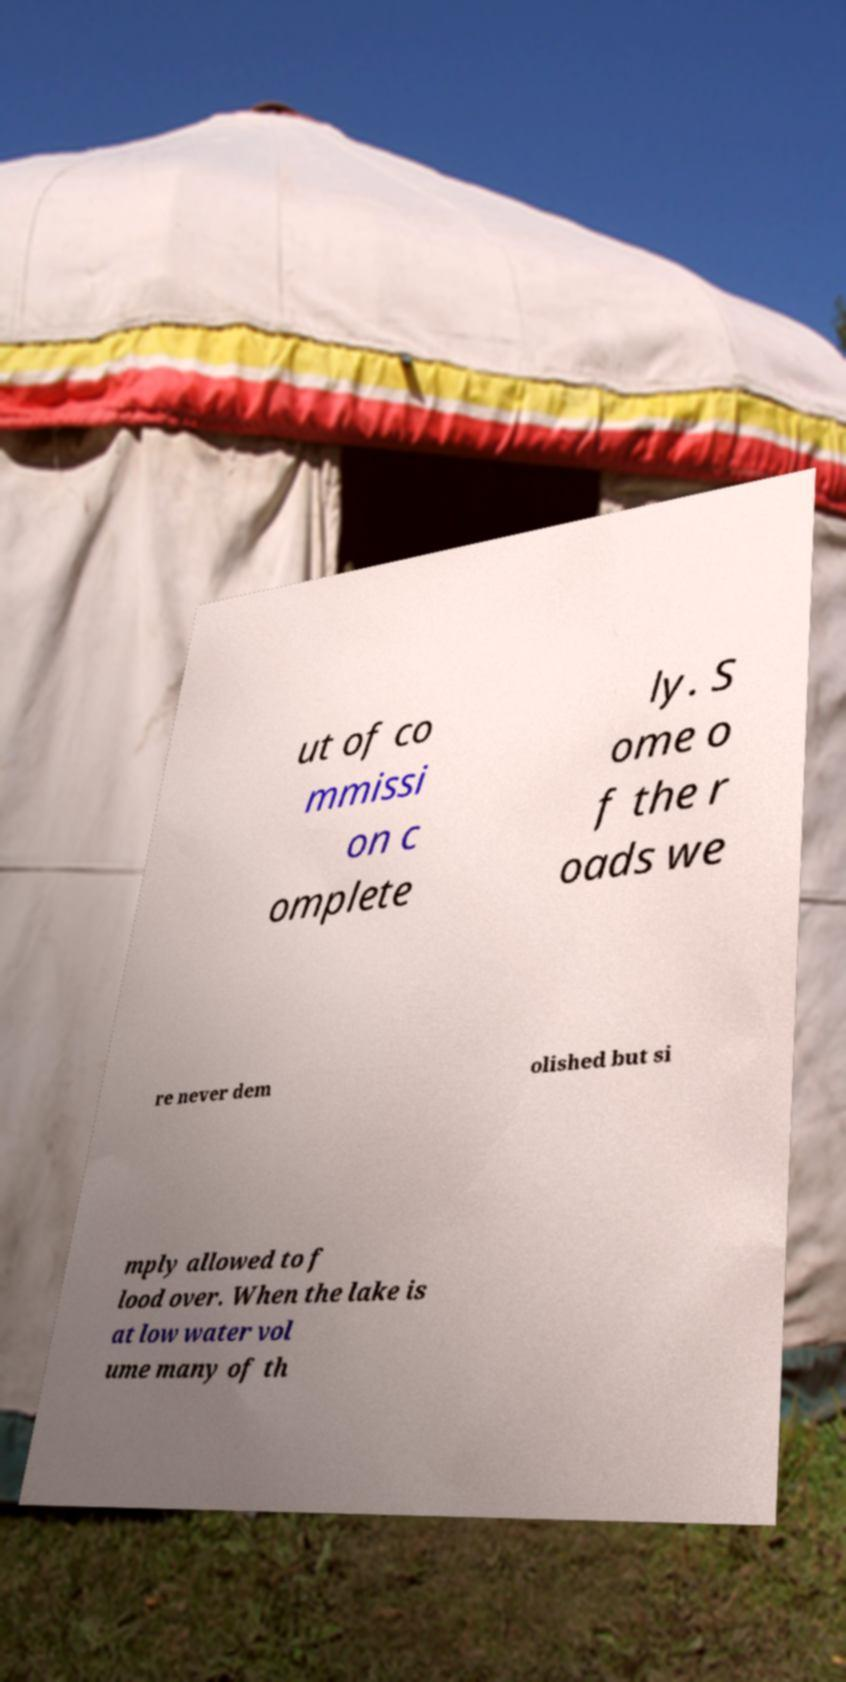What messages or text are displayed in this image? I need them in a readable, typed format. ut of co mmissi on c omplete ly. S ome o f the r oads we re never dem olished but si mply allowed to f lood over. When the lake is at low water vol ume many of th 